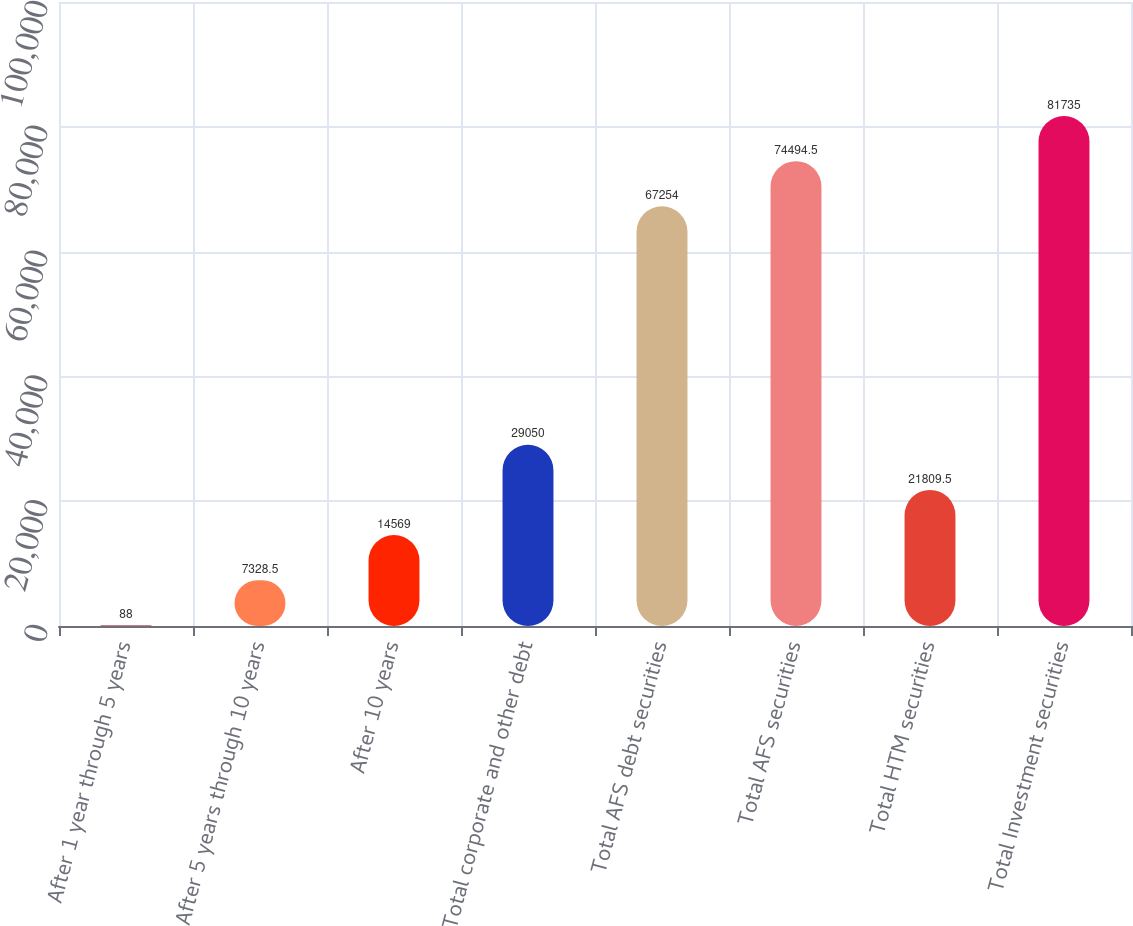<chart> <loc_0><loc_0><loc_500><loc_500><bar_chart><fcel>After 1 year through 5 years<fcel>After 5 years through 10 years<fcel>After 10 years<fcel>Total corporate and other debt<fcel>Total AFS debt securities<fcel>Total AFS securities<fcel>Total HTM securities<fcel>Total Investment securities<nl><fcel>88<fcel>7328.5<fcel>14569<fcel>29050<fcel>67254<fcel>74494.5<fcel>21809.5<fcel>81735<nl></chart> 